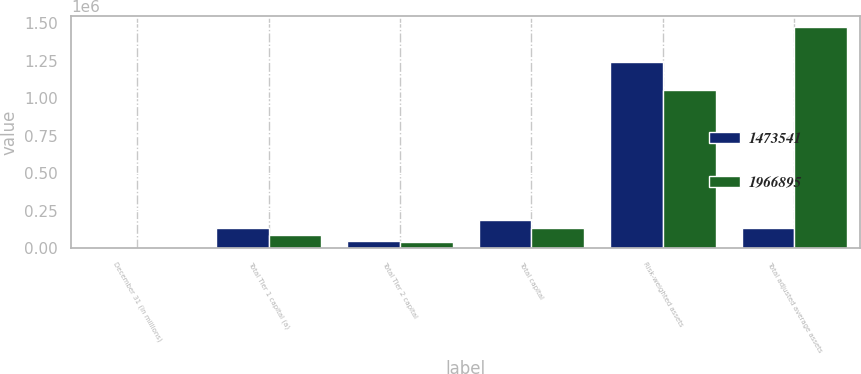<chart> <loc_0><loc_0><loc_500><loc_500><stacked_bar_chart><ecel><fcel>December 31 (in millions)<fcel>Total Tier 1 capital (a)<fcel>Total Tier 2 capital<fcel>Total capital<fcel>Risk-weighted assets<fcel>Total adjusted average assets<nl><fcel>1.47354e+06<fcel>2008<fcel>136104<fcel>48616<fcel>184720<fcel>1.24466e+06<fcel>132242<nl><fcel>1.9669e+06<fcel>2007<fcel>88746<fcel>43496<fcel>132242<fcel>1.05188e+06<fcel>1.47354e+06<nl></chart> 